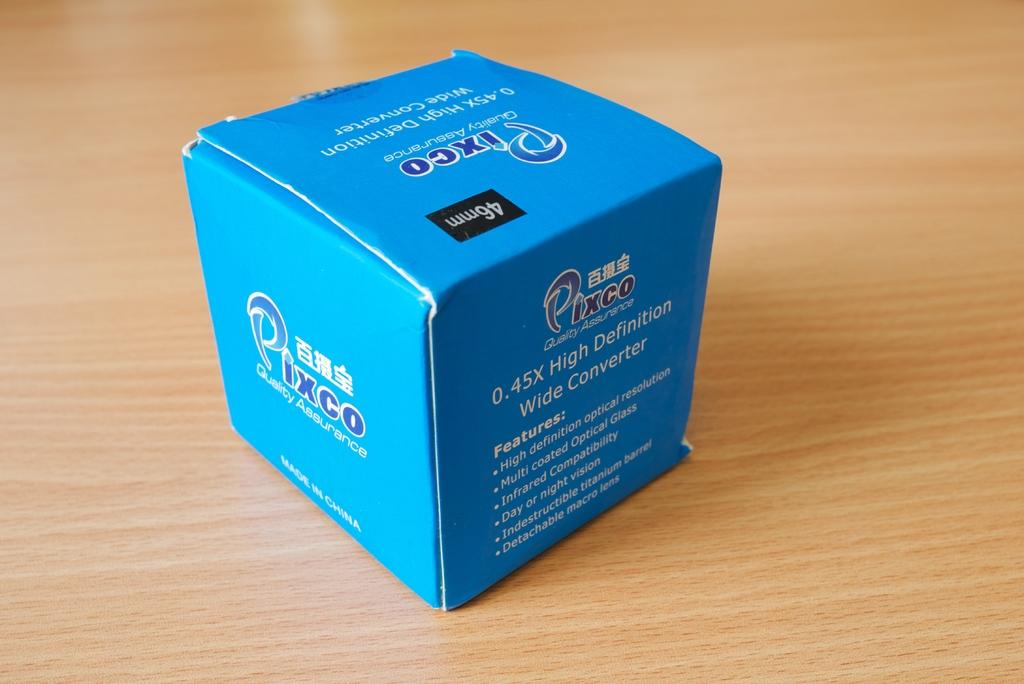<image>
Relay a brief, clear account of the picture shown. A blue box containing Pixco High Definition Wide Converter. 